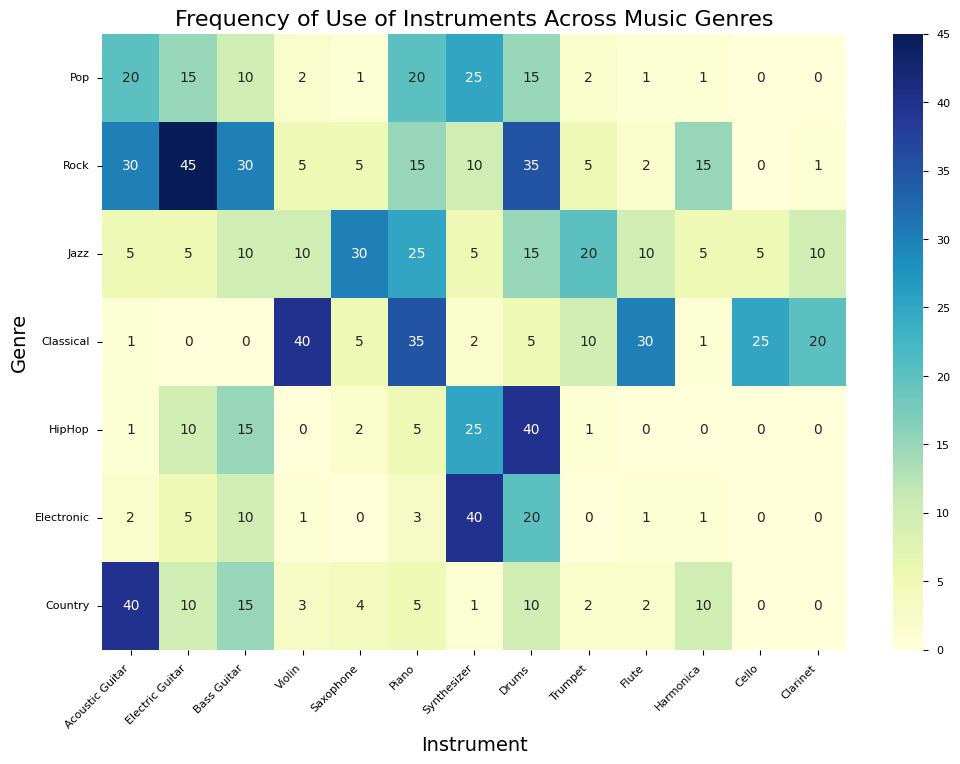Which genre uses the Synthesizer the most? Look at the column for "Synthesizer" and find the highest value among the genres. "Electronic" has the highest frequency with a value of 40.
Answer: Electronic What is the total frequency of use for the Trumpet across all genres? Sum up the values in the "Trumpet" row: 2 (Pop) + 5 (Rock) + 20 (Jazz) + 10 (Classical) + 1 (HipHop) + 0 (Electronic) + 2 (Country).
Answer: 40 Which instrument has the highest frequency in Jazz? In the "Jazz" row, find the highest value. "Saxophone" has the highest frequency with a value of 30.
Answer: Saxophone How many more times is the Piano used in Classical compared to Pop? Look at the "Piano" row and subtract the value for "Pop" (20) from "Classical" (35).
Answer: 15 Is the frequency of the Bass Guitar higher in HipHop or Country? Compare the values in the "Bass Guitar" row for "HipHop" (15) and "Country" (15). They are equal.
Answer: Equal What is the average frequency of use of the Drums across all genres? Sum up the values in the "Drums" row: 15 (Pop) + 35 (Rock) + 15 (Jazz) + 5 (Classical) + 40 (HipHop) + 20 (Electronic) + 10 (Country) = 140. Divide by the number of genres (7). 140 / 7 = 20.
Answer: 20 Which instrument appears the least frequently across all genres? Find the instrument with the lowest total value across all genres. Sum each row and find the minimum total. "Cello" and "Clarinet" both have a total of 25.
Answer: Cello, Clarinet In which genres is the Acoustic Guitar used more frequently than the Electric Guitar? Compare the values in the "Acoustic Guitar" and "Electric Guitar" rows for each genre and identify where the Acoustic Guitar value is higher. These genres are "Classical" and "Country".
Answer: Classical, Country What is the frequency difference between the use of Violin in Classical versus Rock? Subtract the value for "Rock" (5) from "Classical" (40) in the "Violin" row.
Answer: 35 